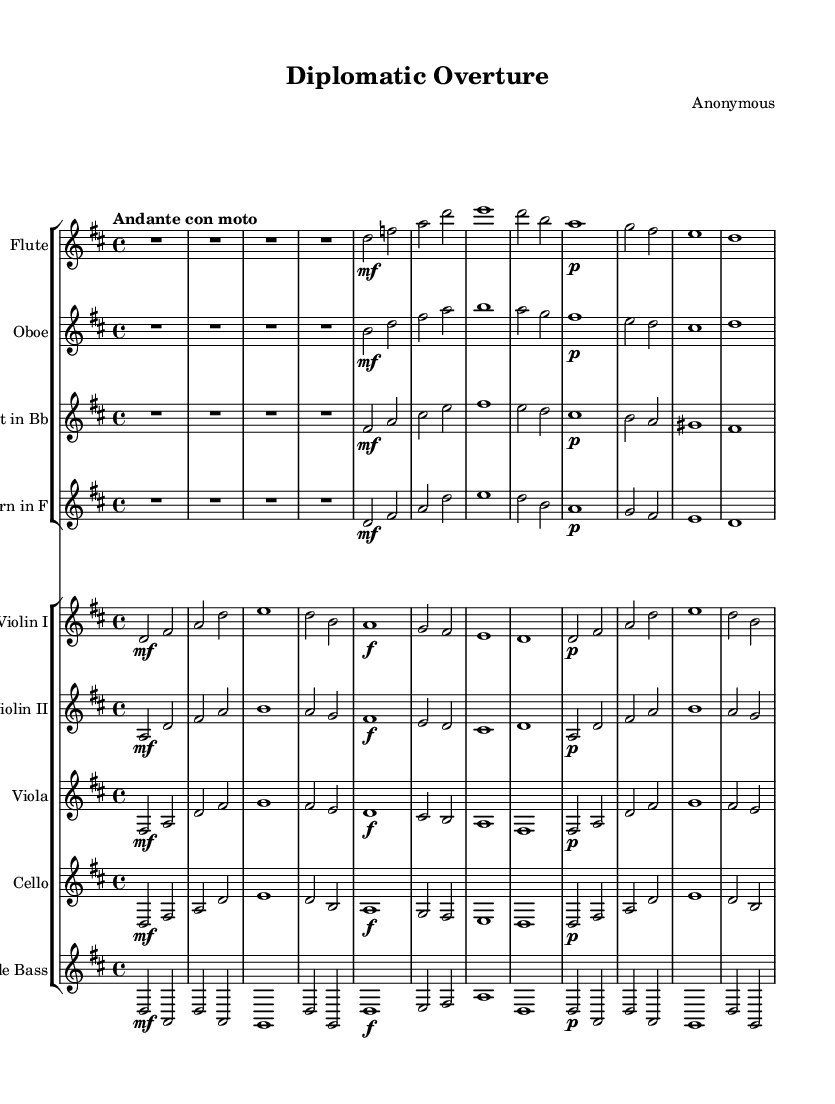What is the key signature of this music? The key signature is D major, which has two sharps: F sharp and C sharp. This is indicated at the beginning of the music sheet.
Answer: D major What is the time signature of this piece? The time signature is 4/4, which means there are four beats in a measure and a quarter note receives one beat. This is shown at the beginning of the music as a fraction.
Answer: 4/4 What is the tempo marking for this composition? The tempo marking is "Andante con moto," which indicates a moderately slow speed with a bit of movement. This is written at the beginning of the music.
Answer: Andante con moto Which instrument plays the melody prominently? The melody is prominently played by the flute, which often carries the main theme in orchestral compositions, as evidenced by its prominent part in the sheet music.
Answer: Flute How many measures are in this composition? There are a total of 16 measures in the composition. This can be counted by looking at the measures indicated by the bar lines throughout the music.
Answer: 16 What dynamics are indicated for the violins in the first section? The dynamics for the violins in the first section indicate "mf" (mezzo-forte), suggesting a moderately loud volume. This is seen in the markings next to the violin parts.
Answer: mf 